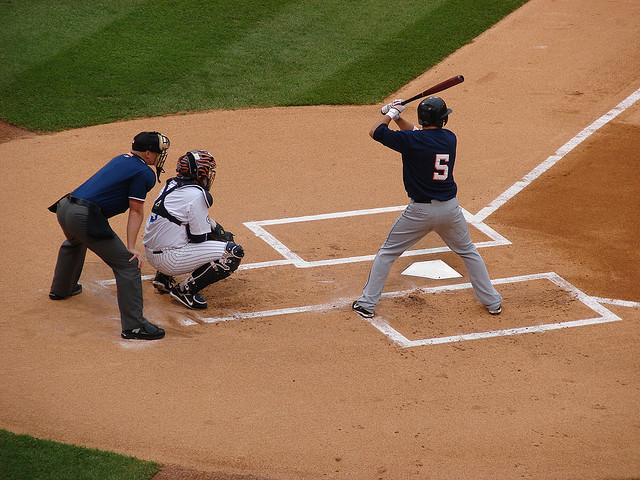Rawlings are the helmets used by whom? Please explain your reasoning. mlb. These are for baseball players 